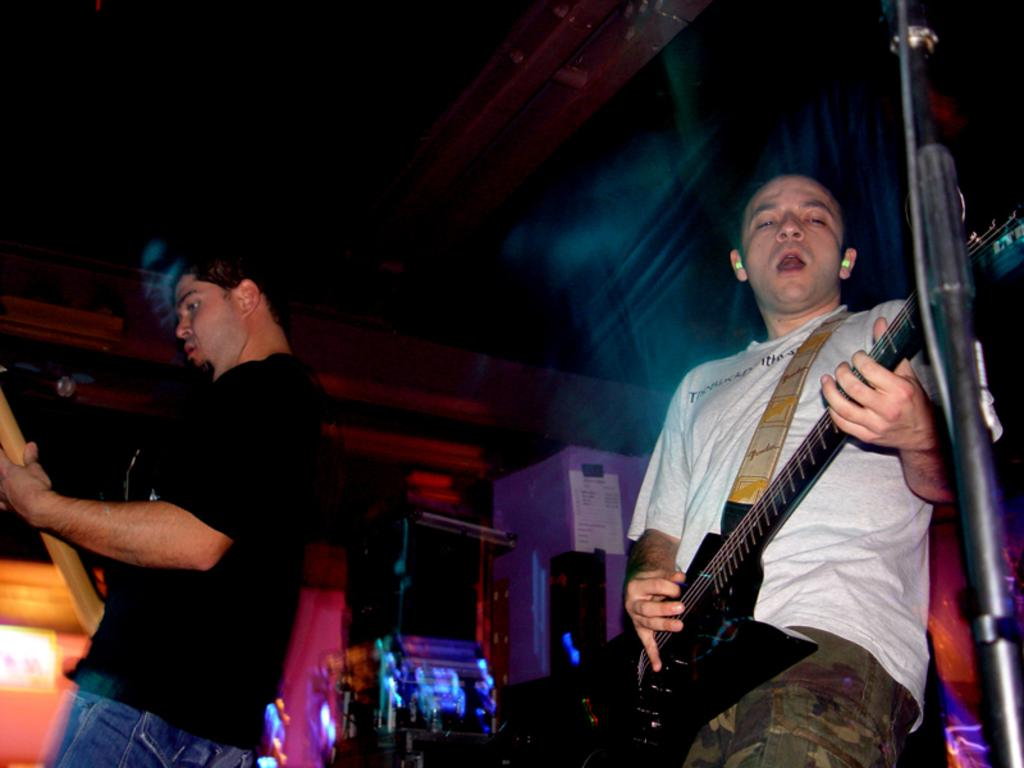How many people are in the image? There are two persons in the image. What are the persons doing in the image? The persons are playing guitar and singing. What is used to hold the microphone in the image? There is a mic holder in the image. What colors are the t-shirts of the two men in the image? One man is wearing a black t-shirt, and another man is wearing a white t-shirt. What is on the wall in the image? There is a poster on the wall. How much does the glove weigh in the image? There is no glove present in the image, so its weight cannot be determined. 